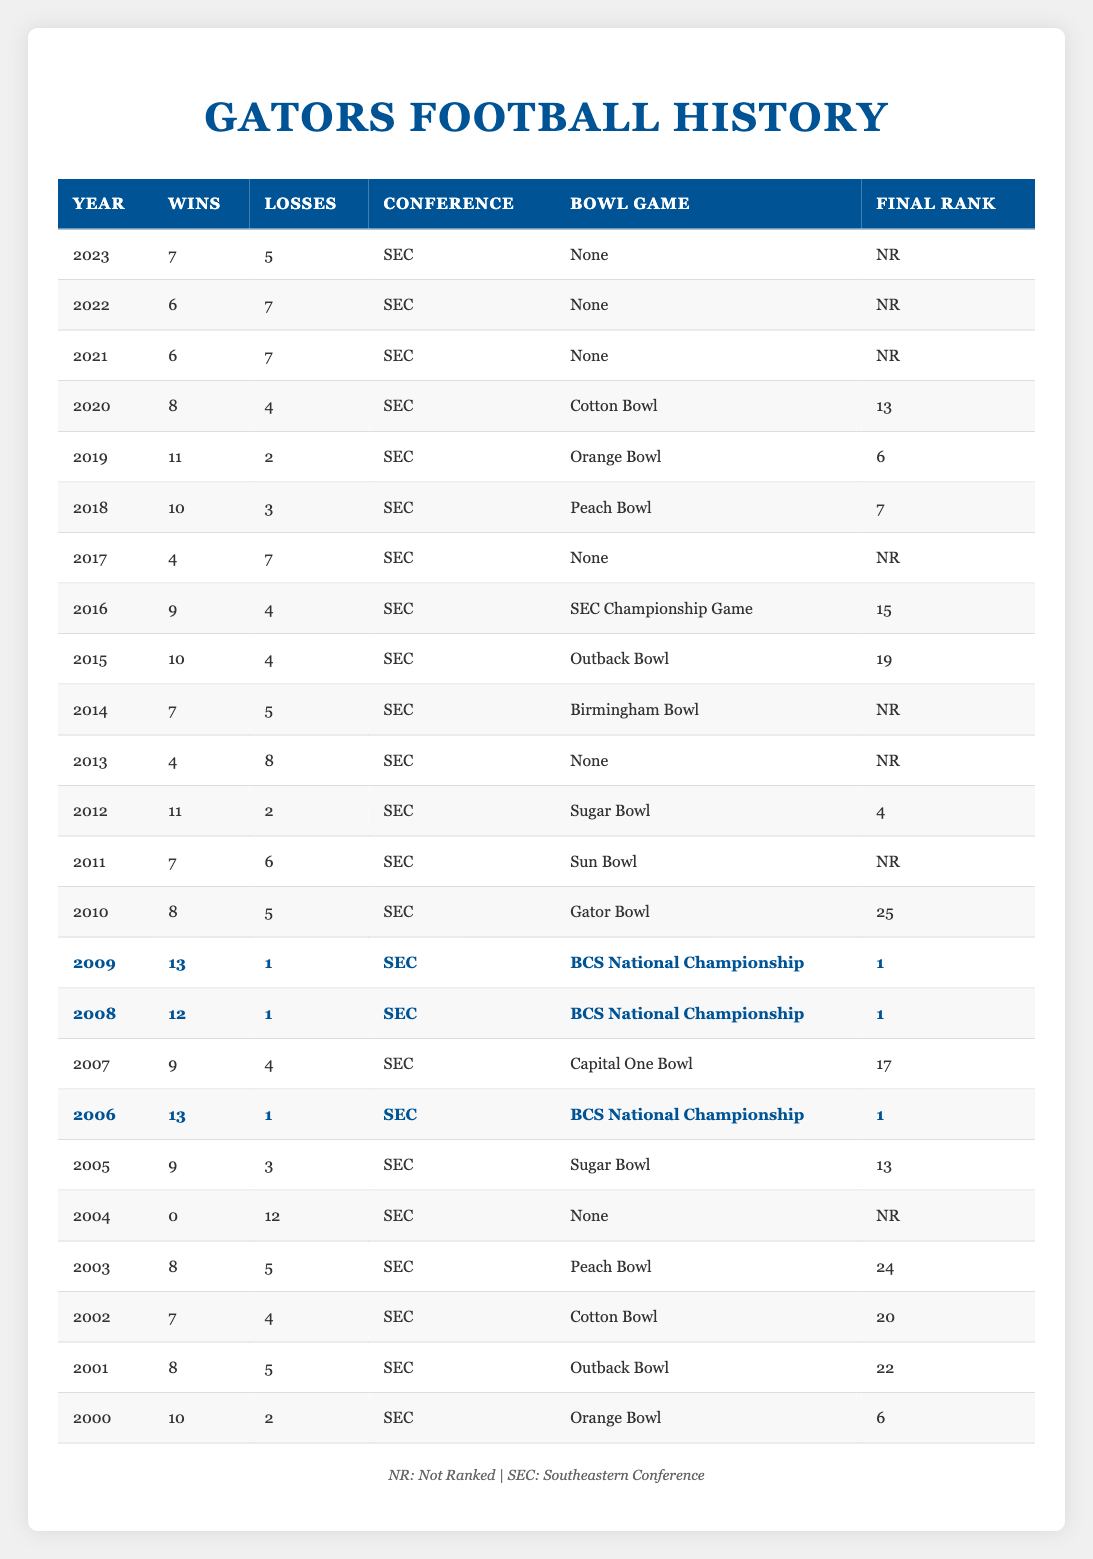What was the Gators' winning record in 2006? The table shows 13 wins and 1 loss for the Gators in 2006. The winning record is calculated as the number of wins over total games played, which is 13 wins + 1 loss = 14 games. Their winning record is 13-1.
Answer: 13-1 In which year did the Gators achieve their lowest total wins? The table indicates that the year 2004 had 0 wins and 12 losses, which is the lowest total wins in the data.
Answer: 2004 How many total wins did the Gators have from 2013 to 2015? Adding the wins from these years: 2013 has 4 wins, 2014 has 7 wins, and 2015 has 10 wins. Thus, the total wins are 4 + 7 + 10 = 21.
Answer: 21 Did the Gators win more than 10 games in any year? By reviewing the table, the years 2006, 2008, and 2009 show 13, 12, and 13 wins respectively, which confirms that they did win more than 10 games in those years.
Answer: Yes What was the average number of wins from 2021 to 2023? Calculating the total wins from 2021 (6), 2022 (6), and 2023 (7) gives us 6 + 6 + 7 = 19. Dividing this by 3 gives us an average of 19 / 3 = 6.33, which rounds to approximately 6.33 wins.
Answer: 6.33 Which year had the highest number of losses? In the table, the year 2004 is the only year with 12 losses, which is the highest.
Answer: 2004 How many times did the Gators play in the BCS National Championship game, and what were the years? The table shows the Gators participated in the BCS National Championship in 2006, 2008, and 2009, totaling 3 times.
Answer: 3 times (years: 2006, 2008, 2009) What is the difference in wins between the years with the most wins and the years with the least wins? The highest wins were 13 in 2006, 2008, and 2009, while the least wins were 0 in 2004. Therefore, the difference is 13 - 0 = 13 wins.
Answer: 13 wins Was the Gators' performance improving from 2019 to 2020? In 2019, the Gators had 11 wins, and in 2020, they had 8 wins. Since 8 is less than 11, their performance was not improving.
Answer: No What is the total number of bowl games the Gators played in from 2020 to 2023? The Gators played in the Cotton Bowl in 2020 and had no bowl games in 2021, 2022, and 2023. Therefore, the total is 1 bowl game.
Answer: 1 bowl game 